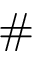Convert formula to latex. <formula><loc_0><loc_0><loc_500><loc_500>\# { \Pi }</formula> 